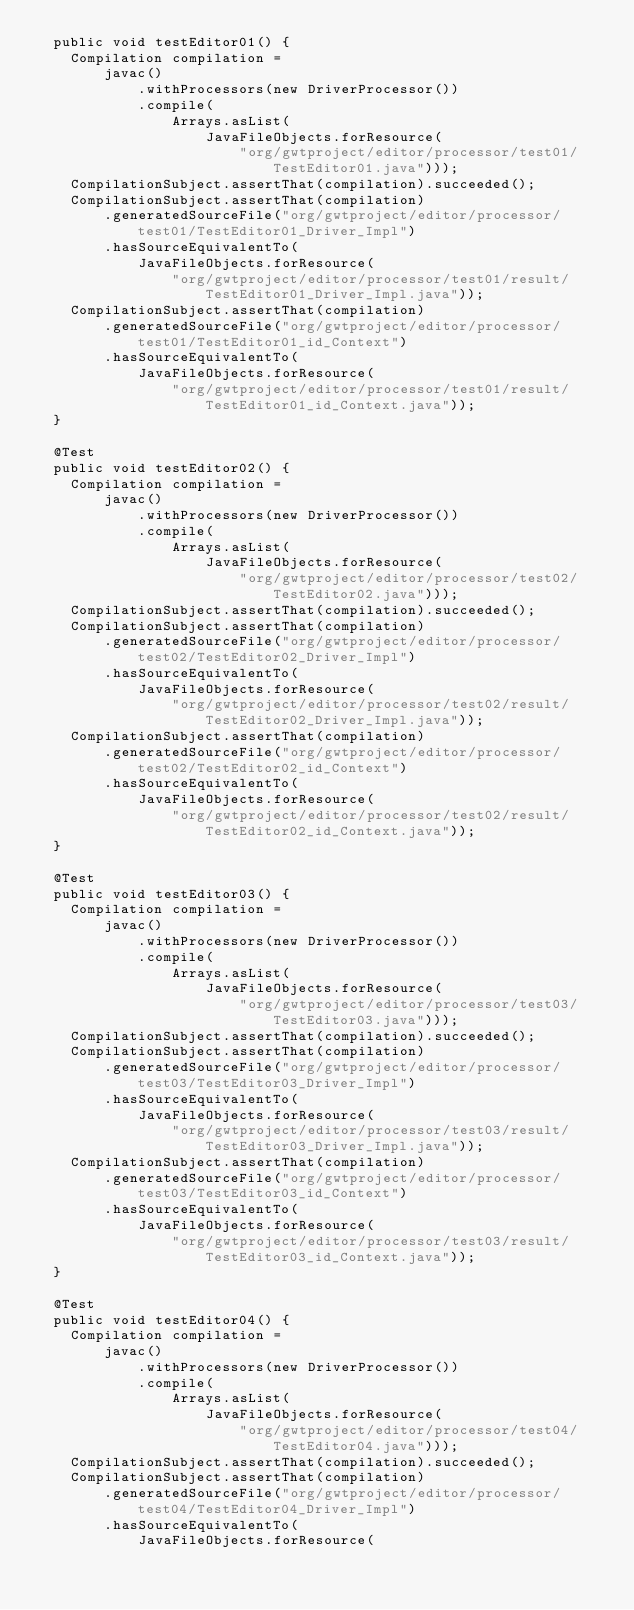Convert code to text. <code><loc_0><loc_0><loc_500><loc_500><_Java_>  public void testEditor01() {
    Compilation compilation =
        javac()
            .withProcessors(new DriverProcessor())
            .compile(
                Arrays.asList(
                    JavaFileObjects.forResource(
                        "org/gwtproject/editor/processor/test01/TestEditor01.java")));
    CompilationSubject.assertThat(compilation).succeeded();
    CompilationSubject.assertThat(compilation)
        .generatedSourceFile("org/gwtproject/editor/processor/test01/TestEditor01_Driver_Impl")
        .hasSourceEquivalentTo(
            JavaFileObjects.forResource(
                "org/gwtproject/editor/processor/test01/result/TestEditor01_Driver_Impl.java"));
    CompilationSubject.assertThat(compilation)
        .generatedSourceFile("org/gwtproject/editor/processor/test01/TestEditor01_id_Context")
        .hasSourceEquivalentTo(
            JavaFileObjects.forResource(
                "org/gwtproject/editor/processor/test01/result/TestEditor01_id_Context.java"));
  }

  @Test
  public void testEditor02() {
    Compilation compilation =
        javac()
            .withProcessors(new DriverProcessor())
            .compile(
                Arrays.asList(
                    JavaFileObjects.forResource(
                        "org/gwtproject/editor/processor/test02/TestEditor02.java")));
    CompilationSubject.assertThat(compilation).succeeded();
    CompilationSubject.assertThat(compilation)
        .generatedSourceFile("org/gwtproject/editor/processor/test02/TestEditor02_Driver_Impl")
        .hasSourceEquivalentTo(
            JavaFileObjects.forResource(
                "org/gwtproject/editor/processor/test02/result/TestEditor02_Driver_Impl.java"));
    CompilationSubject.assertThat(compilation)
        .generatedSourceFile("org/gwtproject/editor/processor/test02/TestEditor02_id_Context")
        .hasSourceEquivalentTo(
            JavaFileObjects.forResource(
                "org/gwtproject/editor/processor/test02/result/TestEditor02_id_Context.java"));
  }

  @Test
  public void testEditor03() {
    Compilation compilation =
        javac()
            .withProcessors(new DriverProcessor())
            .compile(
                Arrays.asList(
                    JavaFileObjects.forResource(
                        "org/gwtproject/editor/processor/test03/TestEditor03.java")));
    CompilationSubject.assertThat(compilation).succeeded();
    CompilationSubject.assertThat(compilation)
        .generatedSourceFile("org/gwtproject/editor/processor/test03/TestEditor03_Driver_Impl")
        .hasSourceEquivalentTo(
            JavaFileObjects.forResource(
                "org/gwtproject/editor/processor/test03/result/TestEditor03_Driver_Impl.java"));
    CompilationSubject.assertThat(compilation)
        .generatedSourceFile("org/gwtproject/editor/processor/test03/TestEditor03_id_Context")
        .hasSourceEquivalentTo(
            JavaFileObjects.forResource(
                "org/gwtproject/editor/processor/test03/result/TestEditor03_id_Context.java"));
  }

  @Test
  public void testEditor04() {
    Compilation compilation =
        javac()
            .withProcessors(new DriverProcessor())
            .compile(
                Arrays.asList(
                    JavaFileObjects.forResource(
                        "org/gwtproject/editor/processor/test04/TestEditor04.java")));
    CompilationSubject.assertThat(compilation).succeeded();
    CompilationSubject.assertThat(compilation)
        .generatedSourceFile("org/gwtproject/editor/processor/test04/TestEditor04_Driver_Impl")
        .hasSourceEquivalentTo(
            JavaFileObjects.forResource(</code> 